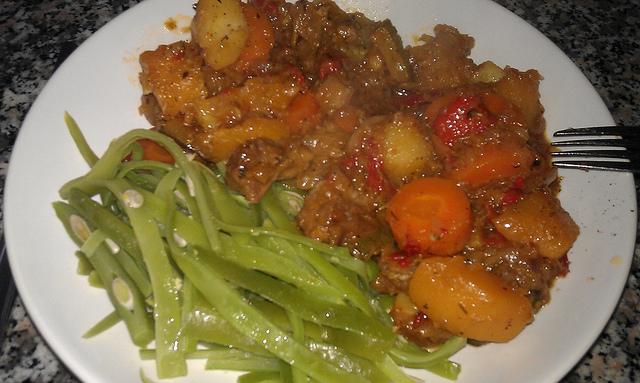What vegetable is on the pasta?
Give a very brief answer. Green beans. Could a vegetarian eat this meal?
Give a very brief answer. No. What country did this food originate from?
Give a very brief answer. India. What is on the plate?
Quick response, please. Food. Is there rice on this plate?
Answer briefly. No. What silverware is sitting on the plate?
Be succinct. Fork. Is there pasta on this plate?
Write a very short answer. No. What kind of food is on the plate?
Answer briefly. Chinese. 